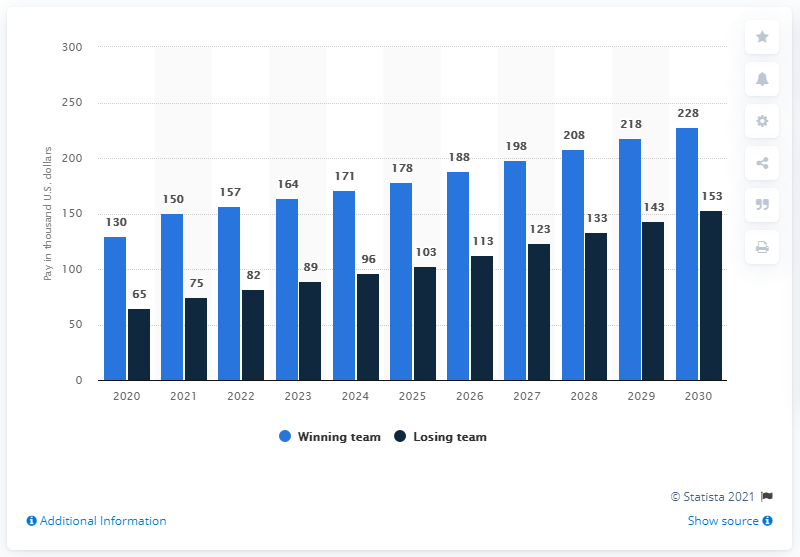Specify some key components in this picture. A player will be paid for participating in the Super Bowl in 2020. The payment for a player participating in the Super Bowl will be made in 2020. 